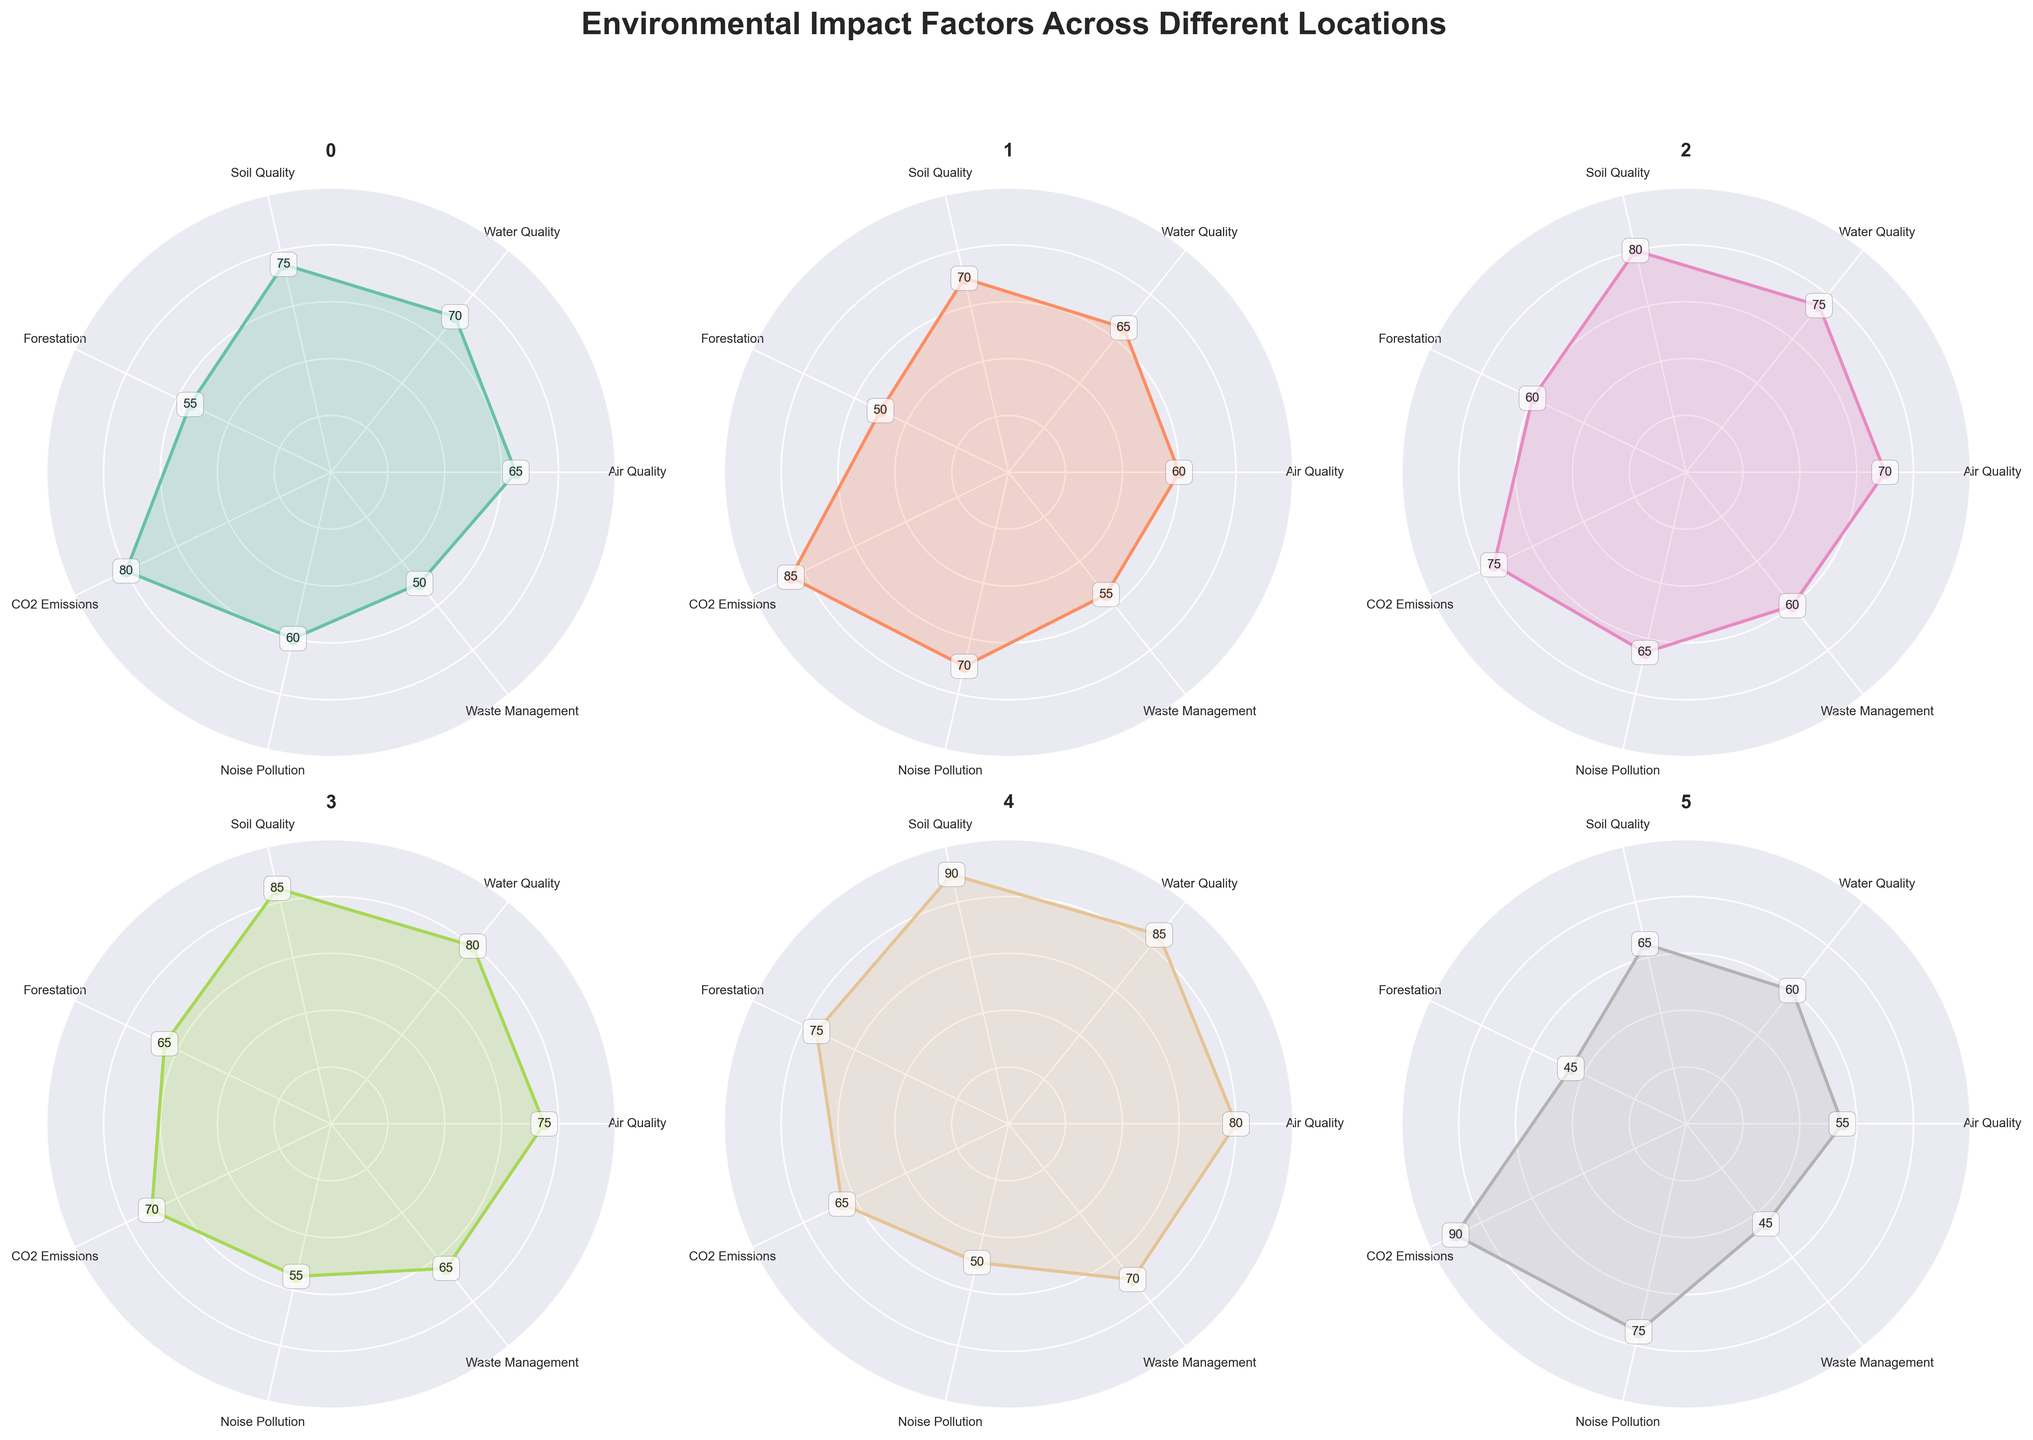Which location has the highest Air Quality score? Observing the radar charts, Seattle has the highest Air Quality score at 80.
Answer: Seattle What are the titles of the subplots? The titles of the subplots correspond to the names of the locations: New York, Los Angeles, Chicago, San Francisco, Seattle, and Houston.
Answer: New York, Los Angeles, Chicago, San Francisco, Seattle, Houston Compare the Water Quality scores between Los Angeles and San Francisco. Which location has a higher score? By comparing the radar charts for Los Angeles (65) and San Francisco (80), San Francisco has a higher Water Quality score.
Answer: San Francisco Which location has the lowest Soil Quality score and what is it? Houston has the lowest Soil Quality score at 65.
Answer: Houston, 65 For New York, how much higher is the Air Quality score compared to Noise Pollution? New York's Air Quality score is 65 and its Noise Pollution score is 60. The difference is 65 - 60 = 5.
Answer: 5 What is the average score for Forestation across all locations? Calculate the average of Forestation values (55, 50, 60, 65, 75, 45) which is (55+50+60+65+75+45) / 6 = 58.33.
Answer: 58.33 Which locations have a CO2 Emissions score greater than 80? By checking each radar chart, New York (80), Los Angeles (85), and Houston (90) have CO2 Emissions scores greater than 80.
Answer: New York, Los Angeles, Houston How does the Waste Management score for Seattle compare to the Waste Management score for New York? Seattle has a Waste Management score of 70, whereas New York has a score of 50. Hence, Seattle's score is higher by 20 points.
Answer: Seattle is higher What is the title of the figure displayed at the top? The title of the figure at the top is 'Environmental Impact Factors Across Different Locations'.
Answer: Environmental Impact Factors Across Different Locations Which location has the most balanced environmental impact factors, judging by the uniformity of the radar chart shape? San Francisco appears to have the most balanced environmental impact factors, shown by its more regular and less spiked radar chart.
Answer: San Francisco 